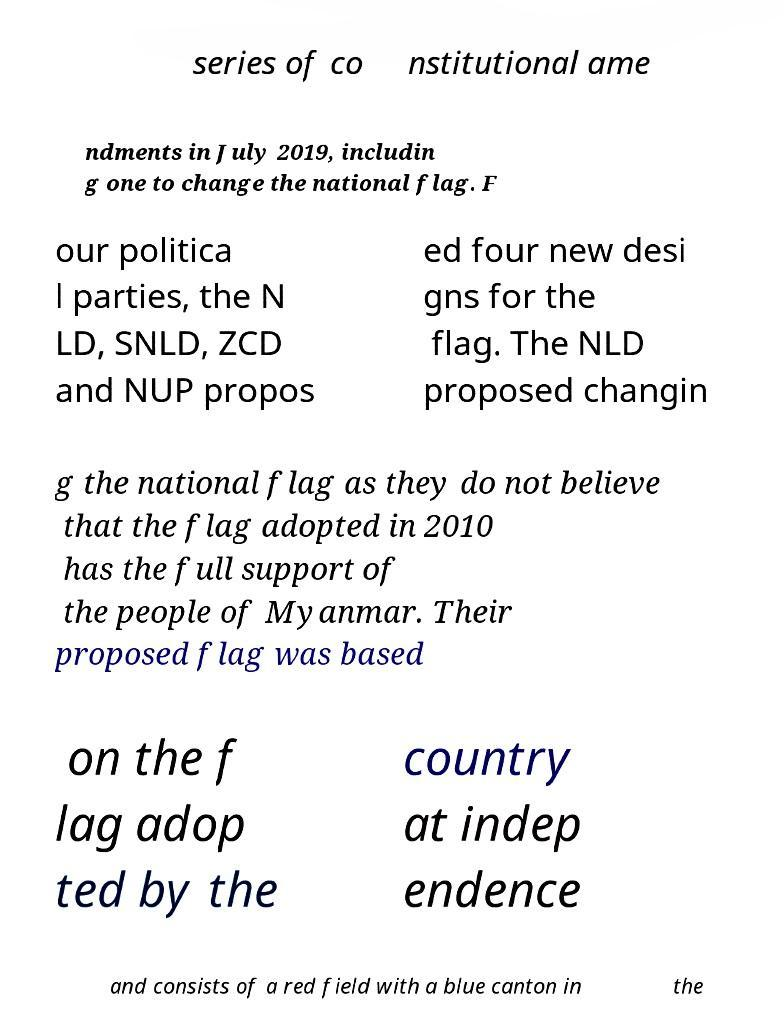What messages or text are displayed in this image? I need them in a readable, typed format. series of co nstitutional ame ndments in July 2019, includin g one to change the national flag. F our politica l parties, the N LD, SNLD, ZCD and NUP propos ed four new desi gns for the flag. The NLD proposed changin g the national flag as they do not believe that the flag adopted in 2010 has the full support of the people of Myanmar. Their proposed flag was based on the f lag adop ted by the country at indep endence and consists of a red field with a blue canton in the 